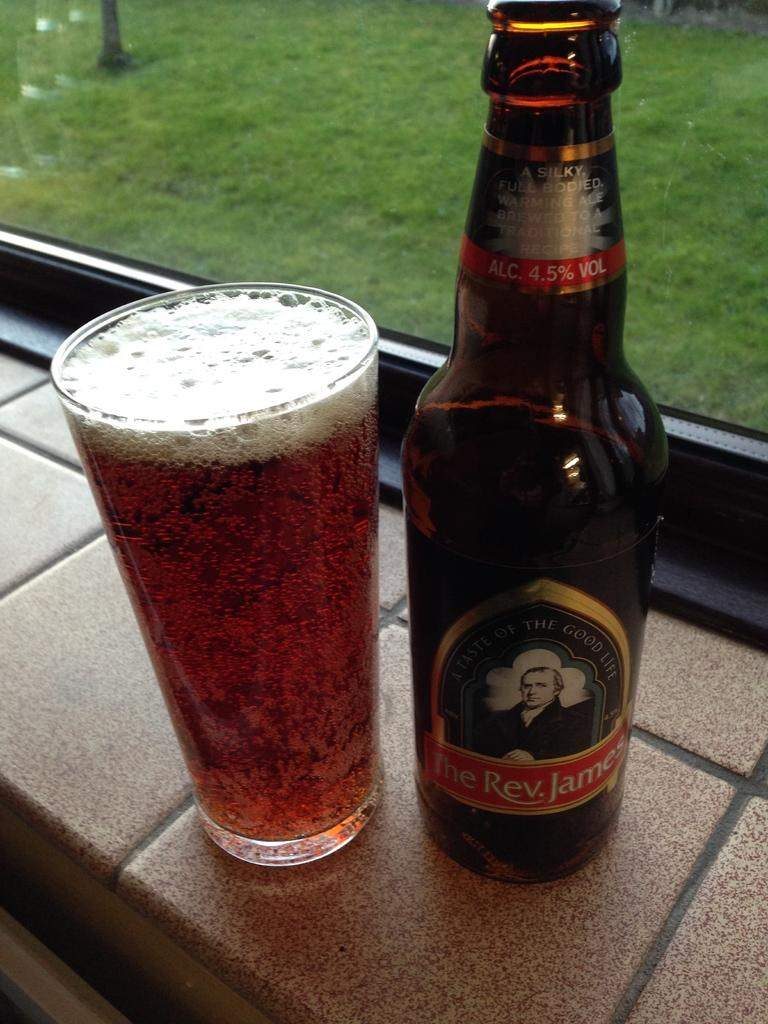Provide a one-sentence caption for the provided image. A glass of beer and a beer bottle of The Rev. James. 